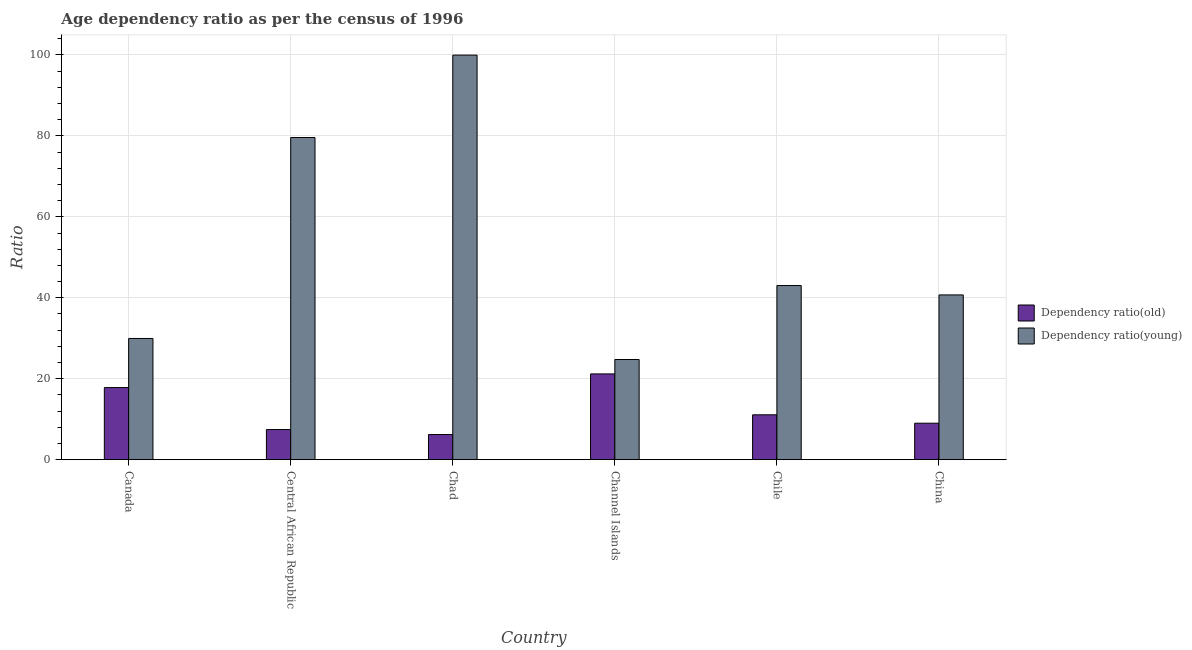How many bars are there on the 3rd tick from the left?
Provide a succinct answer. 2. What is the label of the 2nd group of bars from the left?
Keep it short and to the point. Central African Republic. In how many cases, is the number of bars for a given country not equal to the number of legend labels?
Make the answer very short. 0. What is the age dependency ratio(young) in Chad?
Provide a short and direct response. 99.95. Across all countries, what is the maximum age dependency ratio(young)?
Your answer should be very brief. 99.95. Across all countries, what is the minimum age dependency ratio(young)?
Provide a short and direct response. 24.75. In which country was the age dependency ratio(young) maximum?
Provide a short and direct response. Chad. In which country was the age dependency ratio(old) minimum?
Make the answer very short. Chad. What is the total age dependency ratio(young) in the graph?
Your answer should be very brief. 317.97. What is the difference between the age dependency ratio(old) in Central African Republic and that in Chad?
Provide a succinct answer. 1.23. What is the difference between the age dependency ratio(young) in Canada and the age dependency ratio(old) in Central African Republic?
Your response must be concise. 22.5. What is the average age dependency ratio(young) per country?
Ensure brevity in your answer.  52.99. What is the difference between the age dependency ratio(old) and age dependency ratio(young) in Canada?
Give a very brief answer. -12.13. What is the ratio of the age dependency ratio(old) in Central African Republic to that in Chad?
Keep it short and to the point. 1.2. What is the difference between the highest and the second highest age dependency ratio(young)?
Your answer should be compact. 20.36. What is the difference between the highest and the lowest age dependency ratio(young)?
Offer a terse response. 75.2. In how many countries, is the age dependency ratio(young) greater than the average age dependency ratio(young) taken over all countries?
Ensure brevity in your answer.  2. What does the 1st bar from the left in Central African Republic represents?
Offer a terse response. Dependency ratio(old). What does the 1st bar from the right in China represents?
Offer a very short reply. Dependency ratio(young). How many bars are there?
Keep it short and to the point. 12. Are all the bars in the graph horizontal?
Provide a short and direct response. No. What is the difference between two consecutive major ticks on the Y-axis?
Provide a succinct answer. 20. Does the graph contain any zero values?
Your answer should be compact. No. Does the graph contain grids?
Your answer should be very brief. Yes. How many legend labels are there?
Offer a very short reply. 2. What is the title of the graph?
Give a very brief answer. Age dependency ratio as per the census of 1996. What is the label or title of the Y-axis?
Your answer should be very brief. Ratio. What is the Ratio in Dependency ratio(old) in Canada?
Your answer should be very brief. 17.82. What is the Ratio of Dependency ratio(young) in Canada?
Offer a terse response. 29.95. What is the Ratio of Dependency ratio(old) in Central African Republic?
Your response must be concise. 7.45. What is the Ratio of Dependency ratio(young) in Central African Republic?
Make the answer very short. 79.59. What is the Ratio of Dependency ratio(old) in Chad?
Your answer should be very brief. 6.21. What is the Ratio of Dependency ratio(young) in Chad?
Give a very brief answer. 99.95. What is the Ratio in Dependency ratio(old) in Channel Islands?
Ensure brevity in your answer.  21.19. What is the Ratio in Dependency ratio(young) in Channel Islands?
Make the answer very short. 24.75. What is the Ratio in Dependency ratio(old) in Chile?
Your response must be concise. 11.09. What is the Ratio in Dependency ratio(young) in Chile?
Make the answer very short. 43.02. What is the Ratio in Dependency ratio(old) in China?
Your answer should be very brief. 9.02. What is the Ratio in Dependency ratio(young) in China?
Make the answer very short. 40.71. Across all countries, what is the maximum Ratio of Dependency ratio(old)?
Your answer should be compact. 21.19. Across all countries, what is the maximum Ratio of Dependency ratio(young)?
Provide a short and direct response. 99.95. Across all countries, what is the minimum Ratio of Dependency ratio(old)?
Your answer should be compact. 6.21. Across all countries, what is the minimum Ratio in Dependency ratio(young)?
Offer a terse response. 24.75. What is the total Ratio in Dependency ratio(old) in the graph?
Give a very brief answer. 72.77. What is the total Ratio in Dependency ratio(young) in the graph?
Keep it short and to the point. 317.97. What is the difference between the Ratio of Dependency ratio(old) in Canada and that in Central African Republic?
Your response must be concise. 10.37. What is the difference between the Ratio of Dependency ratio(young) in Canada and that in Central African Republic?
Provide a short and direct response. -49.64. What is the difference between the Ratio of Dependency ratio(old) in Canada and that in Chad?
Give a very brief answer. 11.6. What is the difference between the Ratio in Dependency ratio(young) in Canada and that in Chad?
Your answer should be compact. -70. What is the difference between the Ratio of Dependency ratio(old) in Canada and that in Channel Islands?
Ensure brevity in your answer.  -3.37. What is the difference between the Ratio of Dependency ratio(young) in Canada and that in Channel Islands?
Your response must be concise. 5.2. What is the difference between the Ratio in Dependency ratio(old) in Canada and that in Chile?
Make the answer very short. 6.73. What is the difference between the Ratio of Dependency ratio(young) in Canada and that in Chile?
Provide a short and direct response. -13.07. What is the difference between the Ratio in Dependency ratio(old) in Canada and that in China?
Provide a short and direct response. 8.8. What is the difference between the Ratio of Dependency ratio(young) in Canada and that in China?
Your answer should be compact. -10.76. What is the difference between the Ratio of Dependency ratio(old) in Central African Republic and that in Chad?
Make the answer very short. 1.23. What is the difference between the Ratio of Dependency ratio(young) in Central African Republic and that in Chad?
Provide a succinct answer. -20.36. What is the difference between the Ratio in Dependency ratio(old) in Central African Republic and that in Channel Islands?
Your answer should be compact. -13.74. What is the difference between the Ratio of Dependency ratio(young) in Central African Republic and that in Channel Islands?
Your answer should be compact. 54.84. What is the difference between the Ratio of Dependency ratio(old) in Central African Republic and that in Chile?
Provide a succinct answer. -3.64. What is the difference between the Ratio of Dependency ratio(young) in Central African Republic and that in Chile?
Provide a short and direct response. 36.57. What is the difference between the Ratio of Dependency ratio(old) in Central African Republic and that in China?
Offer a very short reply. -1.57. What is the difference between the Ratio in Dependency ratio(young) in Central African Republic and that in China?
Offer a terse response. 38.88. What is the difference between the Ratio in Dependency ratio(old) in Chad and that in Channel Islands?
Your answer should be very brief. -14.98. What is the difference between the Ratio of Dependency ratio(young) in Chad and that in Channel Islands?
Give a very brief answer. 75.2. What is the difference between the Ratio of Dependency ratio(old) in Chad and that in Chile?
Your answer should be very brief. -4.87. What is the difference between the Ratio of Dependency ratio(young) in Chad and that in Chile?
Provide a short and direct response. 56.92. What is the difference between the Ratio of Dependency ratio(old) in Chad and that in China?
Provide a short and direct response. -2.81. What is the difference between the Ratio of Dependency ratio(young) in Chad and that in China?
Ensure brevity in your answer.  59.24. What is the difference between the Ratio in Dependency ratio(old) in Channel Islands and that in Chile?
Keep it short and to the point. 10.1. What is the difference between the Ratio in Dependency ratio(young) in Channel Islands and that in Chile?
Make the answer very short. -18.27. What is the difference between the Ratio in Dependency ratio(old) in Channel Islands and that in China?
Make the answer very short. 12.17. What is the difference between the Ratio in Dependency ratio(young) in Channel Islands and that in China?
Your response must be concise. -15.96. What is the difference between the Ratio of Dependency ratio(old) in Chile and that in China?
Provide a short and direct response. 2.07. What is the difference between the Ratio of Dependency ratio(young) in Chile and that in China?
Keep it short and to the point. 2.31. What is the difference between the Ratio in Dependency ratio(old) in Canada and the Ratio in Dependency ratio(young) in Central African Republic?
Provide a succinct answer. -61.77. What is the difference between the Ratio of Dependency ratio(old) in Canada and the Ratio of Dependency ratio(young) in Chad?
Make the answer very short. -82.13. What is the difference between the Ratio in Dependency ratio(old) in Canada and the Ratio in Dependency ratio(young) in Channel Islands?
Your response must be concise. -6.93. What is the difference between the Ratio in Dependency ratio(old) in Canada and the Ratio in Dependency ratio(young) in Chile?
Ensure brevity in your answer.  -25.21. What is the difference between the Ratio in Dependency ratio(old) in Canada and the Ratio in Dependency ratio(young) in China?
Offer a very short reply. -22.89. What is the difference between the Ratio of Dependency ratio(old) in Central African Republic and the Ratio of Dependency ratio(young) in Chad?
Offer a terse response. -92.5. What is the difference between the Ratio of Dependency ratio(old) in Central African Republic and the Ratio of Dependency ratio(young) in Channel Islands?
Give a very brief answer. -17.3. What is the difference between the Ratio in Dependency ratio(old) in Central African Republic and the Ratio in Dependency ratio(young) in Chile?
Offer a very short reply. -35.58. What is the difference between the Ratio in Dependency ratio(old) in Central African Republic and the Ratio in Dependency ratio(young) in China?
Provide a succinct answer. -33.26. What is the difference between the Ratio of Dependency ratio(old) in Chad and the Ratio of Dependency ratio(young) in Channel Islands?
Give a very brief answer. -18.54. What is the difference between the Ratio of Dependency ratio(old) in Chad and the Ratio of Dependency ratio(young) in Chile?
Ensure brevity in your answer.  -36.81. What is the difference between the Ratio in Dependency ratio(old) in Chad and the Ratio in Dependency ratio(young) in China?
Make the answer very short. -34.49. What is the difference between the Ratio of Dependency ratio(old) in Channel Islands and the Ratio of Dependency ratio(young) in Chile?
Offer a very short reply. -21.83. What is the difference between the Ratio in Dependency ratio(old) in Channel Islands and the Ratio in Dependency ratio(young) in China?
Your answer should be very brief. -19.52. What is the difference between the Ratio of Dependency ratio(old) in Chile and the Ratio of Dependency ratio(young) in China?
Ensure brevity in your answer.  -29.62. What is the average Ratio of Dependency ratio(old) per country?
Your answer should be compact. 12.13. What is the average Ratio in Dependency ratio(young) per country?
Make the answer very short. 52.99. What is the difference between the Ratio in Dependency ratio(old) and Ratio in Dependency ratio(young) in Canada?
Make the answer very short. -12.13. What is the difference between the Ratio of Dependency ratio(old) and Ratio of Dependency ratio(young) in Central African Republic?
Provide a short and direct response. -72.14. What is the difference between the Ratio of Dependency ratio(old) and Ratio of Dependency ratio(young) in Chad?
Offer a very short reply. -93.73. What is the difference between the Ratio of Dependency ratio(old) and Ratio of Dependency ratio(young) in Channel Islands?
Your answer should be very brief. -3.56. What is the difference between the Ratio in Dependency ratio(old) and Ratio in Dependency ratio(young) in Chile?
Give a very brief answer. -31.94. What is the difference between the Ratio in Dependency ratio(old) and Ratio in Dependency ratio(young) in China?
Provide a succinct answer. -31.69. What is the ratio of the Ratio in Dependency ratio(old) in Canada to that in Central African Republic?
Your answer should be very brief. 2.39. What is the ratio of the Ratio in Dependency ratio(young) in Canada to that in Central African Republic?
Your response must be concise. 0.38. What is the ratio of the Ratio in Dependency ratio(old) in Canada to that in Chad?
Your answer should be compact. 2.87. What is the ratio of the Ratio in Dependency ratio(young) in Canada to that in Chad?
Your answer should be compact. 0.3. What is the ratio of the Ratio in Dependency ratio(old) in Canada to that in Channel Islands?
Give a very brief answer. 0.84. What is the ratio of the Ratio of Dependency ratio(young) in Canada to that in Channel Islands?
Keep it short and to the point. 1.21. What is the ratio of the Ratio of Dependency ratio(old) in Canada to that in Chile?
Ensure brevity in your answer.  1.61. What is the ratio of the Ratio of Dependency ratio(young) in Canada to that in Chile?
Your answer should be very brief. 0.7. What is the ratio of the Ratio of Dependency ratio(old) in Canada to that in China?
Offer a terse response. 1.98. What is the ratio of the Ratio of Dependency ratio(young) in Canada to that in China?
Ensure brevity in your answer.  0.74. What is the ratio of the Ratio in Dependency ratio(old) in Central African Republic to that in Chad?
Your response must be concise. 1.2. What is the ratio of the Ratio in Dependency ratio(young) in Central African Republic to that in Chad?
Give a very brief answer. 0.8. What is the ratio of the Ratio in Dependency ratio(old) in Central African Republic to that in Channel Islands?
Offer a very short reply. 0.35. What is the ratio of the Ratio in Dependency ratio(young) in Central African Republic to that in Channel Islands?
Keep it short and to the point. 3.22. What is the ratio of the Ratio of Dependency ratio(old) in Central African Republic to that in Chile?
Give a very brief answer. 0.67. What is the ratio of the Ratio in Dependency ratio(young) in Central African Republic to that in Chile?
Your answer should be very brief. 1.85. What is the ratio of the Ratio of Dependency ratio(old) in Central African Republic to that in China?
Make the answer very short. 0.83. What is the ratio of the Ratio in Dependency ratio(young) in Central African Republic to that in China?
Give a very brief answer. 1.96. What is the ratio of the Ratio of Dependency ratio(old) in Chad to that in Channel Islands?
Ensure brevity in your answer.  0.29. What is the ratio of the Ratio in Dependency ratio(young) in Chad to that in Channel Islands?
Offer a very short reply. 4.04. What is the ratio of the Ratio of Dependency ratio(old) in Chad to that in Chile?
Provide a succinct answer. 0.56. What is the ratio of the Ratio in Dependency ratio(young) in Chad to that in Chile?
Give a very brief answer. 2.32. What is the ratio of the Ratio of Dependency ratio(old) in Chad to that in China?
Provide a short and direct response. 0.69. What is the ratio of the Ratio of Dependency ratio(young) in Chad to that in China?
Keep it short and to the point. 2.46. What is the ratio of the Ratio in Dependency ratio(old) in Channel Islands to that in Chile?
Your answer should be compact. 1.91. What is the ratio of the Ratio in Dependency ratio(young) in Channel Islands to that in Chile?
Offer a terse response. 0.58. What is the ratio of the Ratio in Dependency ratio(old) in Channel Islands to that in China?
Provide a succinct answer. 2.35. What is the ratio of the Ratio of Dependency ratio(young) in Channel Islands to that in China?
Offer a terse response. 0.61. What is the ratio of the Ratio in Dependency ratio(old) in Chile to that in China?
Offer a very short reply. 1.23. What is the ratio of the Ratio of Dependency ratio(young) in Chile to that in China?
Give a very brief answer. 1.06. What is the difference between the highest and the second highest Ratio in Dependency ratio(old)?
Provide a short and direct response. 3.37. What is the difference between the highest and the second highest Ratio in Dependency ratio(young)?
Keep it short and to the point. 20.36. What is the difference between the highest and the lowest Ratio of Dependency ratio(old)?
Make the answer very short. 14.98. What is the difference between the highest and the lowest Ratio in Dependency ratio(young)?
Give a very brief answer. 75.2. 